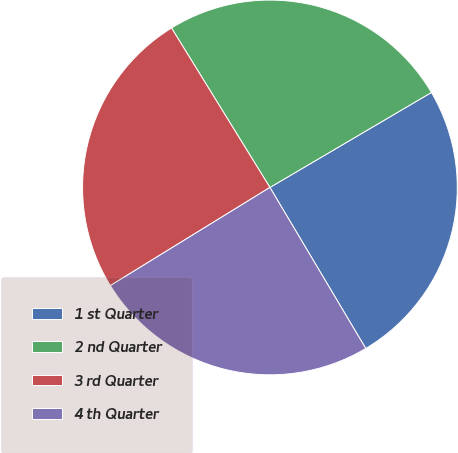<chart> <loc_0><loc_0><loc_500><loc_500><pie_chart><fcel>1 st Quarter<fcel>2 nd Quarter<fcel>3 rd Quarter<fcel>4 th Quarter<nl><fcel>24.92%<fcel>25.34%<fcel>24.98%<fcel>24.77%<nl></chart> 